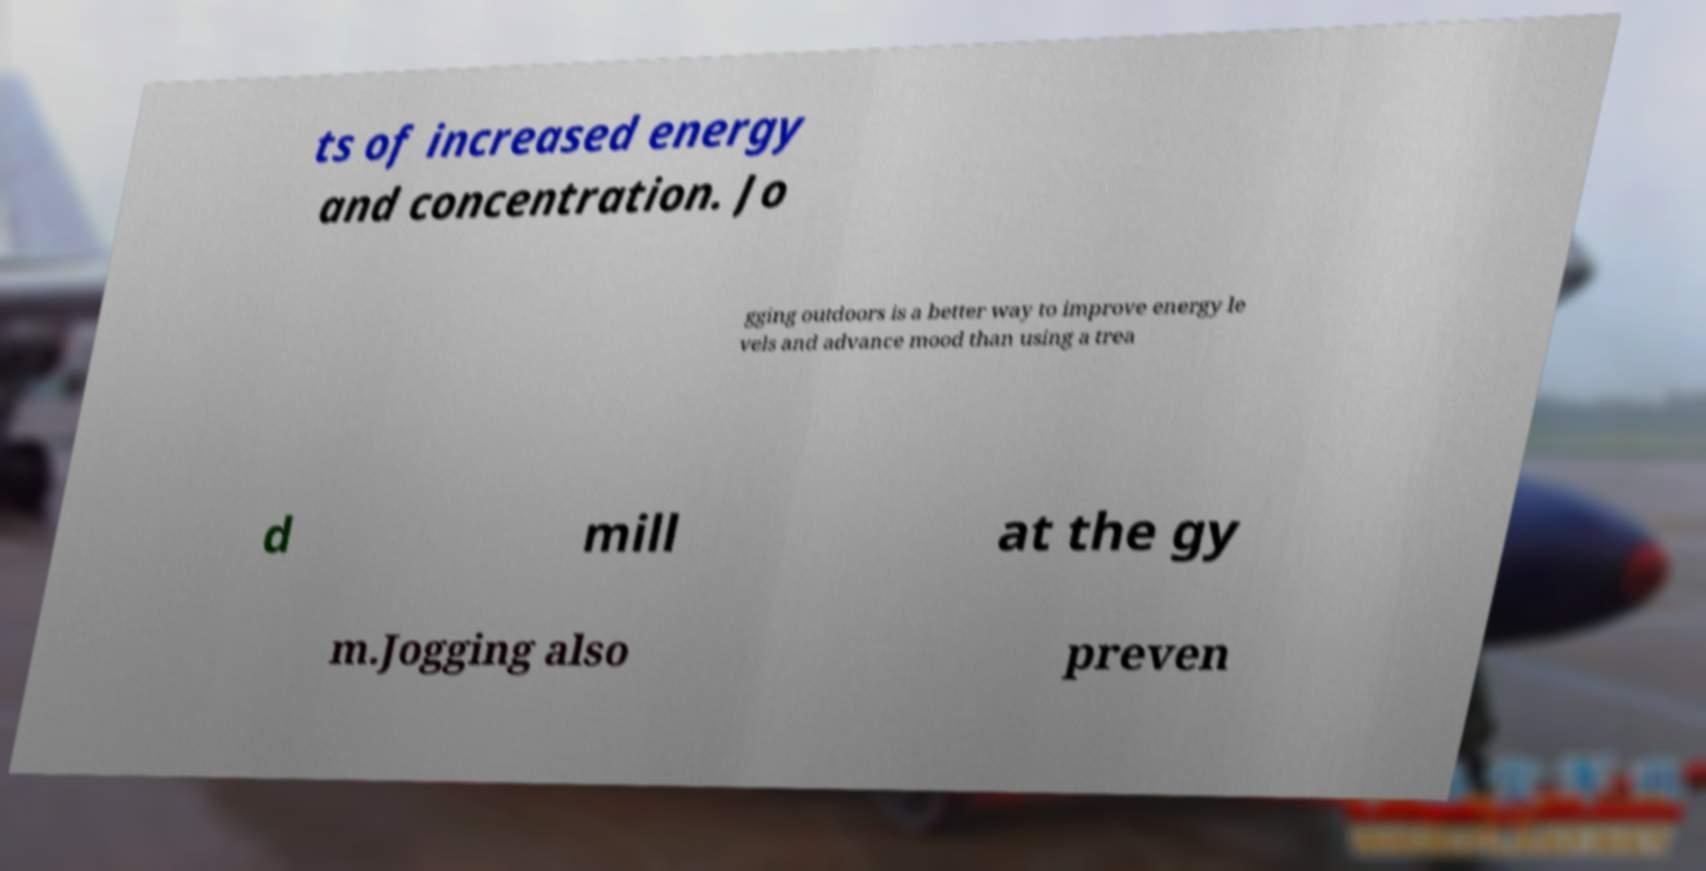Please identify and transcribe the text found in this image. ts of increased energy and concentration. Jo gging outdoors is a better way to improve energy le vels and advance mood than using a trea d mill at the gy m.Jogging also preven 